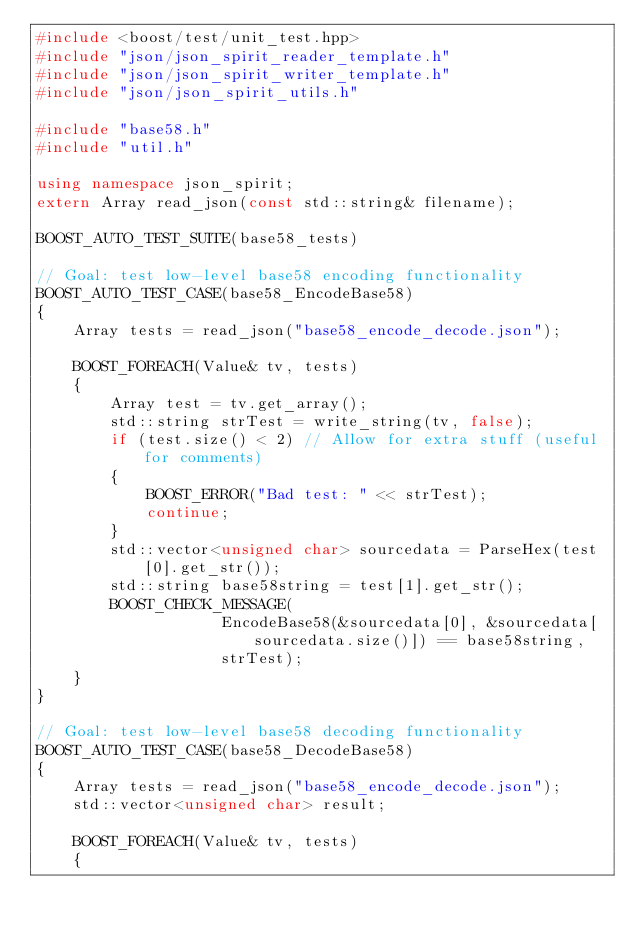<code> <loc_0><loc_0><loc_500><loc_500><_C++_>#include <boost/test/unit_test.hpp>
#include "json/json_spirit_reader_template.h"
#include "json/json_spirit_writer_template.h"
#include "json/json_spirit_utils.h"

#include "base58.h"
#include "util.h"

using namespace json_spirit;
extern Array read_json(const std::string& filename);

BOOST_AUTO_TEST_SUITE(base58_tests)

// Goal: test low-level base58 encoding functionality
BOOST_AUTO_TEST_CASE(base58_EncodeBase58)
{
    Array tests = read_json("base58_encode_decode.json");

    BOOST_FOREACH(Value& tv, tests)
    {
        Array test = tv.get_array();
        std::string strTest = write_string(tv, false);
        if (test.size() < 2) // Allow for extra stuff (useful for comments)
        {
            BOOST_ERROR("Bad test: " << strTest);
            continue;
        }
        std::vector<unsigned char> sourcedata = ParseHex(test[0].get_str());
        std::string base58string = test[1].get_str();
        BOOST_CHECK_MESSAGE(
                    EncodeBase58(&sourcedata[0], &sourcedata[sourcedata.size()]) == base58string,
                    strTest);
    }
}

// Goal: test low-level base58 decoding functionality
BOOST_AUTO_TEST_CASE(base58_DecodeBase58)
{
    Array tests = read_json("base58_encode_decode.json");
    std::vector<unsigned char> result;

    BOOST_FOREACH(Value& tv, tests)
    {</code> 